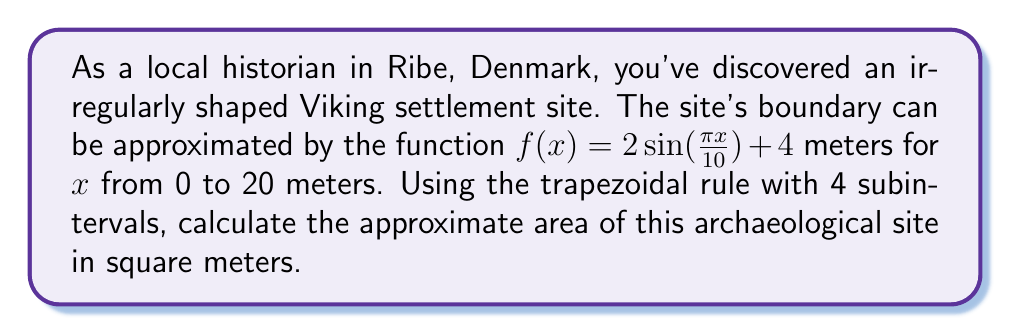Solve this math problem. Let's approach this problem step-by-step using the trapezoidal rule:

1) The trapezoidal rule for numerical integration is given by:

   $$\int_{a}^{b} f(x) dx \approx \frac{h}{2}[f(x_0) + 2f(x_1) + 2f(x_2) + ... + 2f(x_{n-1}) + f(x_n)]$$

   Where $h = \frac{b-a}{n}$, and $n$ is the number of subintervals.

2) In our case, $a=0$, $b=20$, and $n=4$. So, $h = \frac{20-0}{4} = 5$ meters.

3) We need to calculate $f(x)$ at $x = 0, 5, 10, 15,$ and $20$:

   $f(0) = 2\sin(0) + 4 = 4$
   $f(5) = 2\sin(\frac{\pi}{2}) + 4 = 6$
   $f(10) = 2\sin(\pi) + 4 = 4$
   $f(15) = 2\sin(\frac{3\pi}{2}) + 4 = 2$
   $f(20) = 2\sin(2\pi) + 4 = 4$

4) Applying the trapezoidal rule:

   $$Area \approx \frac{5}{2}[4 + 2(6) + 2(4) + 2(2) + 4]$$
   $$= \frac{5}{2}[4 + 12 + 8 + 4 + 4]$$
   $$= \frac{5}{2}[32]$$
   $$= 80$$

5) The units are in square meters, as we integrated length (in meters) with respect to width (in meters).

Therefore, the approximate area of the Viking settlement site is 80 square meters.
Answer: 80 square meters 